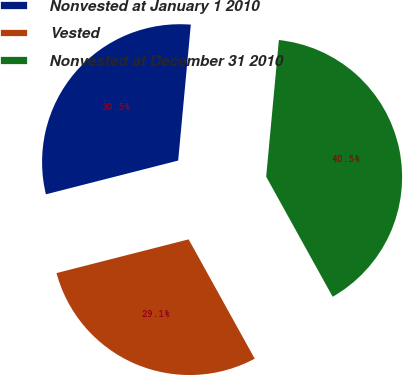<chart> <loc_0><loc_0><loc_500><loc_500><pie_chart><fcel>Nonvested at January 1 2010<fcel>Vested<fcel>Nonvested at December 31 2010<nl><fcel>30.45%<fcel>29.07%<fcel>40.47%<nl></chart> 